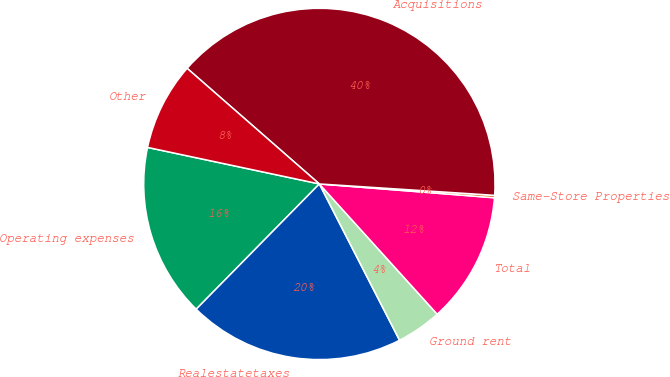<chart> <loc_0><loc_0><loc_500><loc_500><pie_chart><fcel>Operating expenses<fcel>Realestatetaxes<fcel>Ground rent<fcel>Total<fcel>Same-Store Properties<fcel>Acquisitions<fcel>Other<nl><fcel>15.97%<fcel>19.91%<fcel>4.16%<fcel>12.04%<fcel>0.22%<fcel>39.6%<fcel>8.1%<nl></chart> 